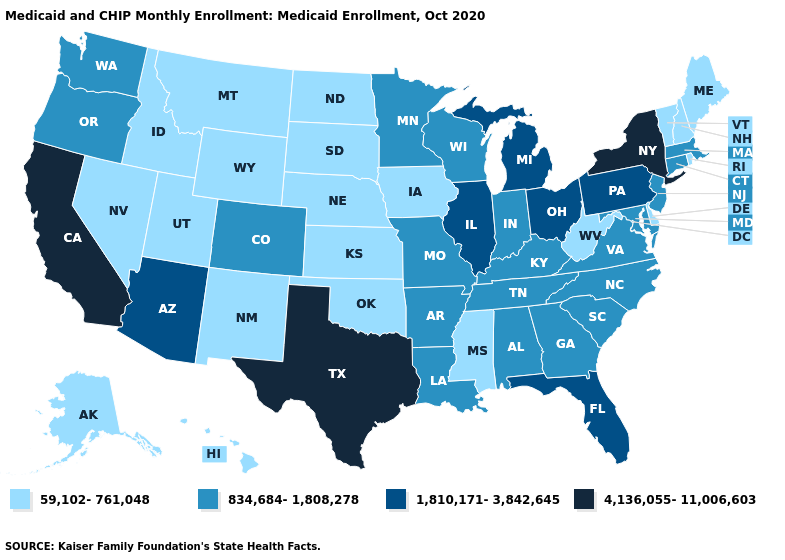Does the first symbol in the legend represent the smallest category?
Quick response, please. Yes. What is the value of Massachusetts?
Short answer required. 834,684-1,808,278. Which states hav the highest value in the Northeast?
Concise answer only. New York. Name the states that have a value in the range 834,684-1,808,278?
Quick response, please. Alabama, Arkansas, Colorado, Connecticut, Georgia, Indiana, Kentucky, Louisiana, Maryland, Massachusetts, Minnesota, Missouri, New Jersey, North Carolina, Oregon, South Carolina, Tennessee, Virginia, Washington, Wisconsin. Does Mississippi have the highest value in the South?
Concise answer only. No. What is the highest value in states that border Minnesota?
Write a very short answer. 834,684-1,808,278. Which states hav the highest value in the Northeast?
Give a very brief answer. New York. Is the legend a continuous bar?
Answer briefly. No. Which states have the highest value in the USA?
Give a very brief answer. California, New York, Texas. Does Colorado have a higher value than Minnesota?
Concise answer only. No. Which states hav the highest value in the MidWest?
Answer briefly. Illinois, Michigan, Ohio. What is the value of Idaho?
Short answer required. 59,102-761,048. What is the value of Tennessee?
Short answer required. 834,684-1,808,278. Name the states that have a value in the range 4,136,055-11,006,603?
Answer briefly. California, New York, Texas. Name the states that have a value in the range 1,810,171-3,842,645?
Keep it brief. Arizona, Florida, Illinois, Michigan, Ohio, Pennsylvania. 